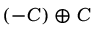Convert formula to latex. <formula><loc_0><loc_0><loc_500><loc_500>( - C ) \oplus C</formula> 